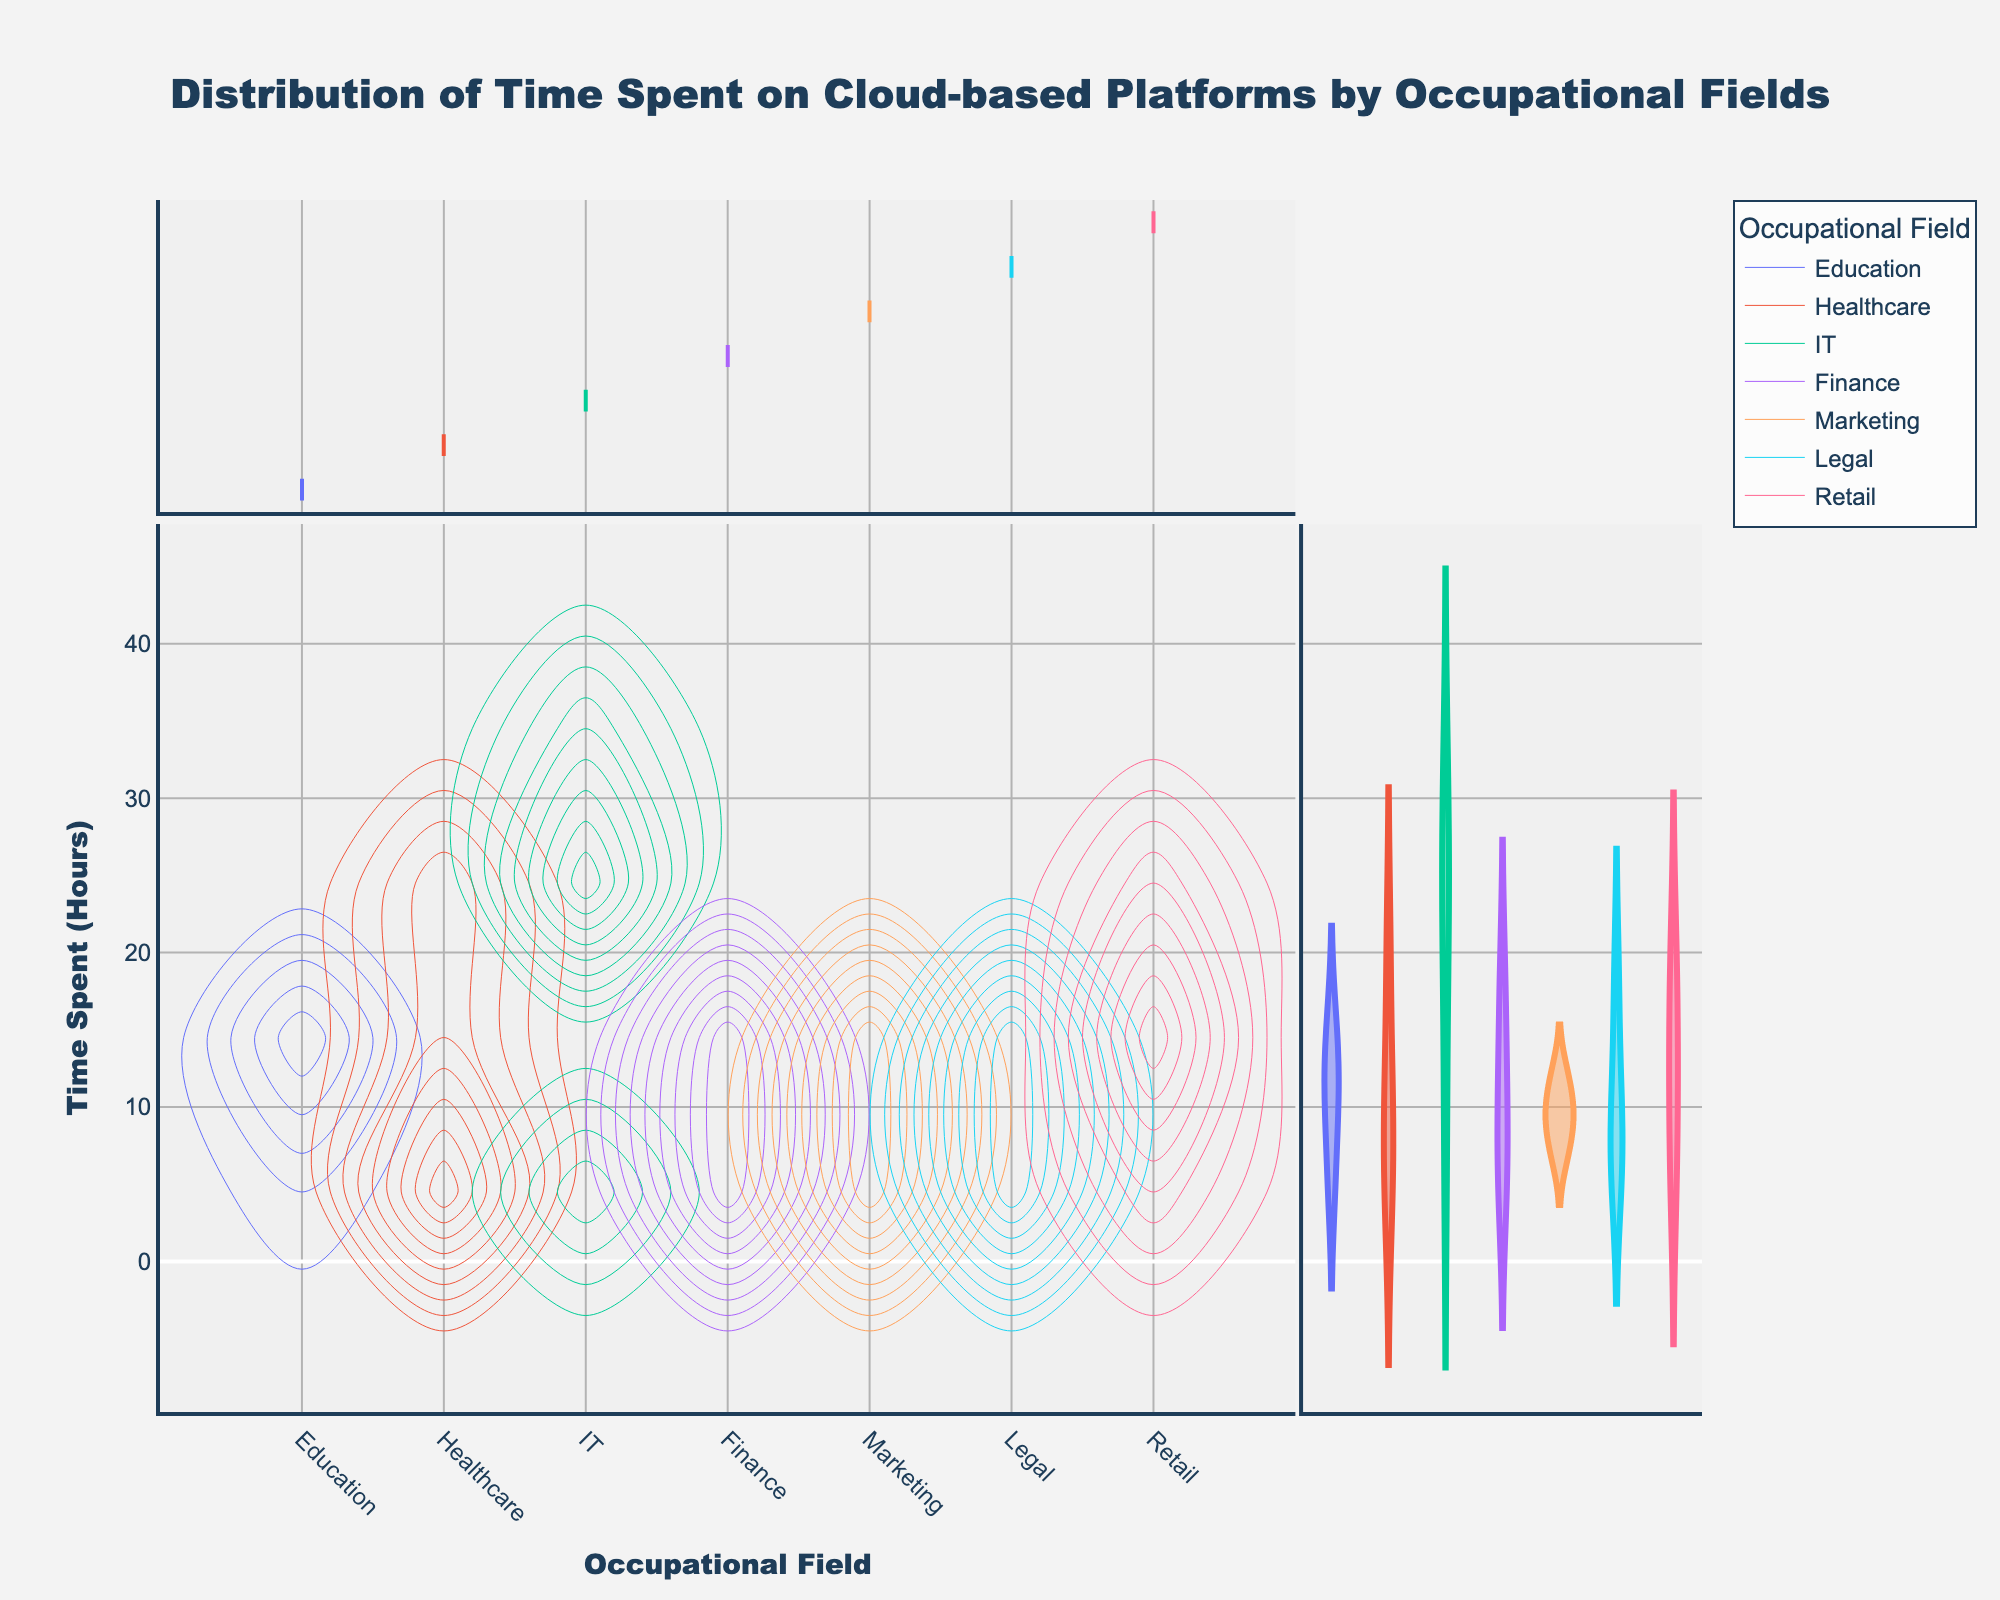What is the title of the figure? The title is typically placed at the top of the figure and describes the main topic or focus. From its placement and size, the title is "Distribution of Time Spent on Cloud-based Platforms by Occupational Fields".
Answer: Distribution of Time Spent on Cloud-based Platforms by Occupational Fields What does the x-axis represent? The x-axis usually represents the independent variable or category. Here, it is labeled "Occupational Field," indicating it represents different occupational fields.
Answer: Occupational Field What does the y-axis represent? The y-axis typically represents the dependent variable or metric being measured. Here, it is labeled "Time Spent (Hours)," indicating it represents the number of hours spent on cloud-based platforms.
Answer: Time Spent (Hours) Which occupational field shows the widest spread of hours spent on cloud-based platforms? To assess the spread, look at the range and dispersion in the density plot for each occupational field. IT shows the widest spread of hours, indicating a wide variation in time spent.
Answer: IT How are the colors used in the figure? The colors separate different occupational fields. Each field is distinctly colored to differentiate its data distribution in the density plot.
Answer: To differentiate occupational fields Which occupational field has the highest peak in the density plot? The highest peak can be identified by finding the tallest contour in the density plot. IT shows the highest peak, indicating the most significant concentration of time spent in a particular range.
Answer: IT What is the average time spent on cloud-based platforms by the Education field? Calculate the average time by summing the hours spent in Education and dividing by the number of entries. The time spent is 15 + 10 + 12 + 5 = 42. There are 4 entries, so the average is 42/4 = 10.5 hours.
Answer: 10.5 hours Compare the median time spent on cloud-based platforms between Finance and Healthcare fields. The median is the middle value in a sorted list. For Finance: [5, 7, 12, 18] - median is (7+12)/2 = 9.5 hours. For Healthcare: [4, 8, 10, 20] - median is (8+10)/2 = 9 hours. Finance has a median of 9.5 hours, which is slightly higher.
Answer: Finance has a higher median Which field shows the least variation in time spent on cloud-based platforms? The field with the least variation can be identified by the narrowest and most clustered distribution. Legal shows the least variation with a narrow and consistent spread.
Answer: Legal 